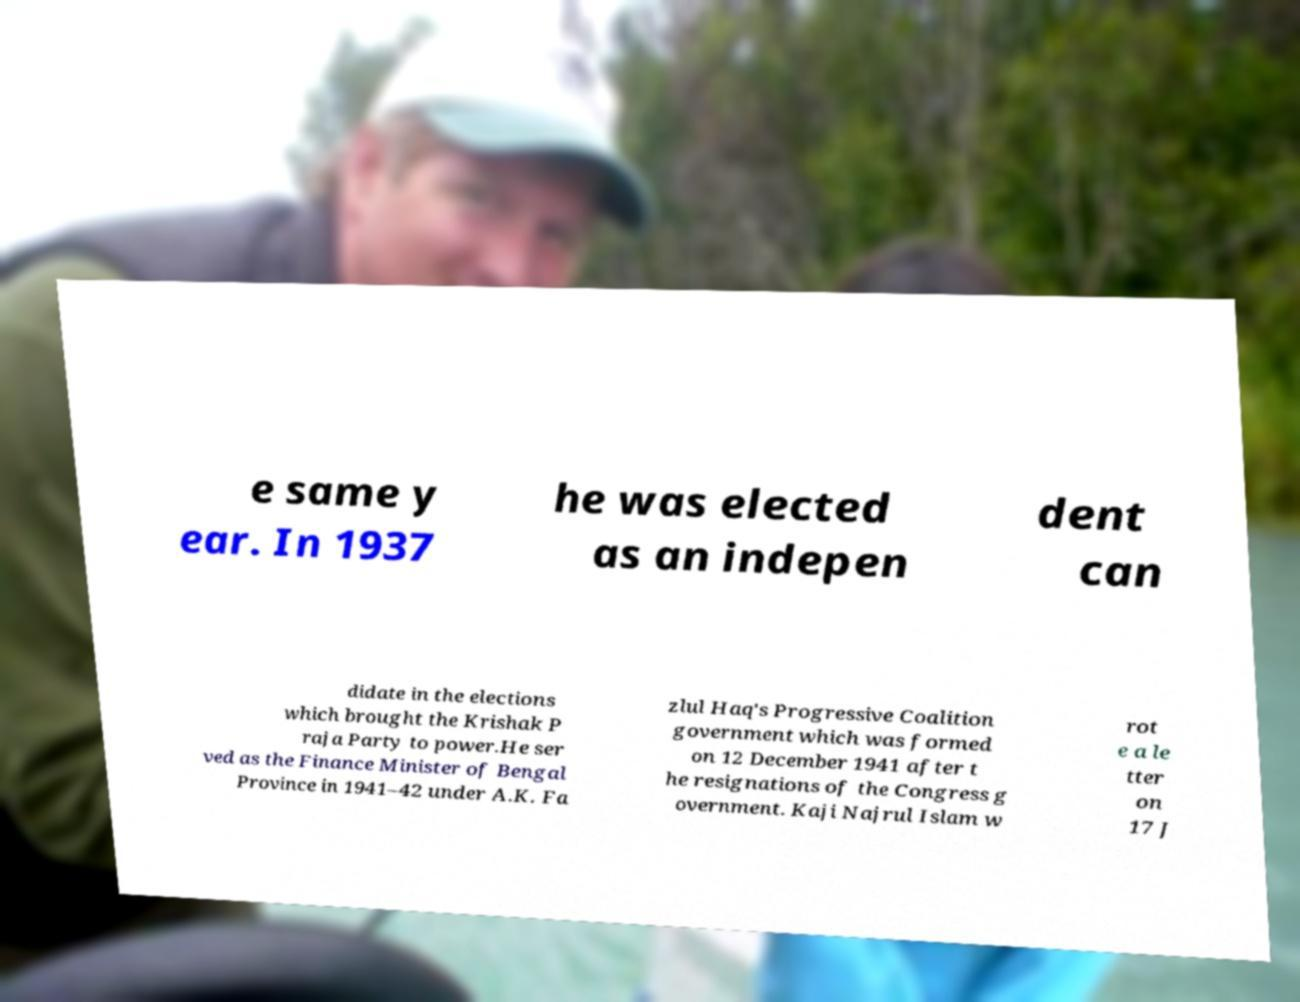Could you assist in decoding the text presented in this image and type it out clearly? e same y ear. In 1937 he was elected as an indepen dent can didate in the elections which brought the Krishak P raja Party to power.He ser ved as the Finance Minister of Bengal Province in 1941–42 under A.K. Fa zlul Haq's Progressive Coalition government which was formed on 12 December 1941 after t he resignations of the Congress g overnment. Kaji Najrul Islam w rot e a le tter on 17 J 